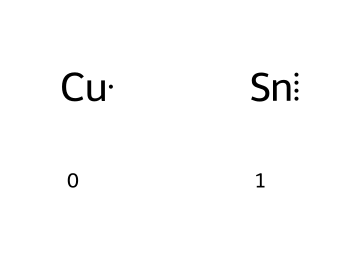What metals make up the bronze in this chemical structure? The chemical structure consists of copper (Cu) and tin (Sn) as indicated by the symbols.
Answer: copper and tin How many different types of elements are present in the structure? The structure has two types of elements: copper and tin.
Answer: two What is the bonding situation in this chemical structure? The structure shows two separate metal atoms, indicating they are not chemically bonded in this representation, but they form an alloy in bronze.
Answer: alloy How does the presence of copper affect the properties of bronze? Copper adds strength and corrosion resistance to the alloy, which is a key trait of bronze armor used in ancient Greece.
Answer: strength What percentage of tin is typically found in bronze? The standard composition of bronze often contains about 10% tin, although this can vary.
Answer: 10 percent Which part of this chemical indicates that it is a metal alloy? The presence of two different metal elements, copper and tin, indicates that it forms a metal alloy rather than a singular metal compound.
Answer: two metals 